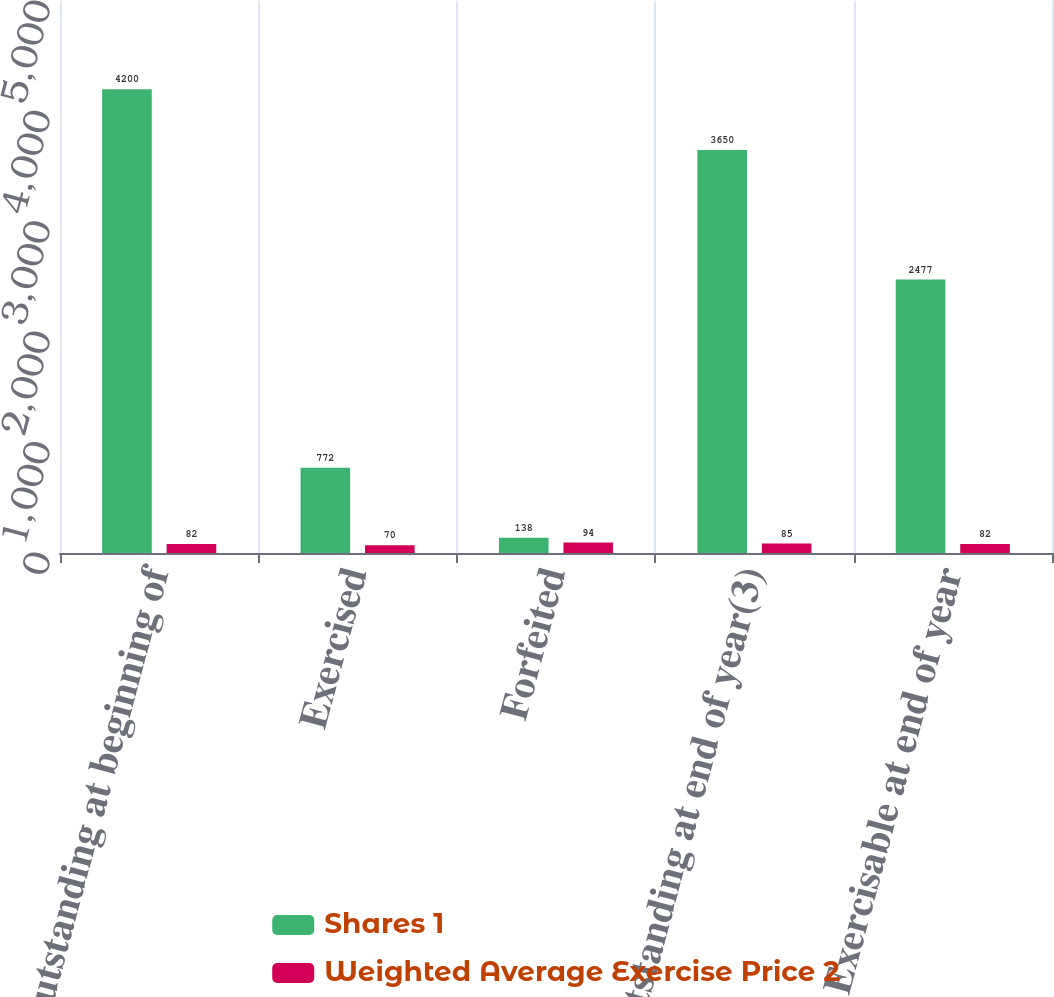<chart> <loc_0><loc_0><loc_500><loc_500><stacked_bar_chart><ecel><fcel>Outstanding at beginning of<fcel>Exercised<fcel>Forfeited<fcel>Outstanding at end of year(3)<fcel>Exercisable at end of year<nl><fcel>Shares 1<fcel>4200<fcel>772<fcel>138<fcel>3650<fcel>2477<nl><fcel>Weighted Average Exercise Price 2<fcel>82<fcel>70<fcel>94<fcel>85<fcel>82<nl></chart> 